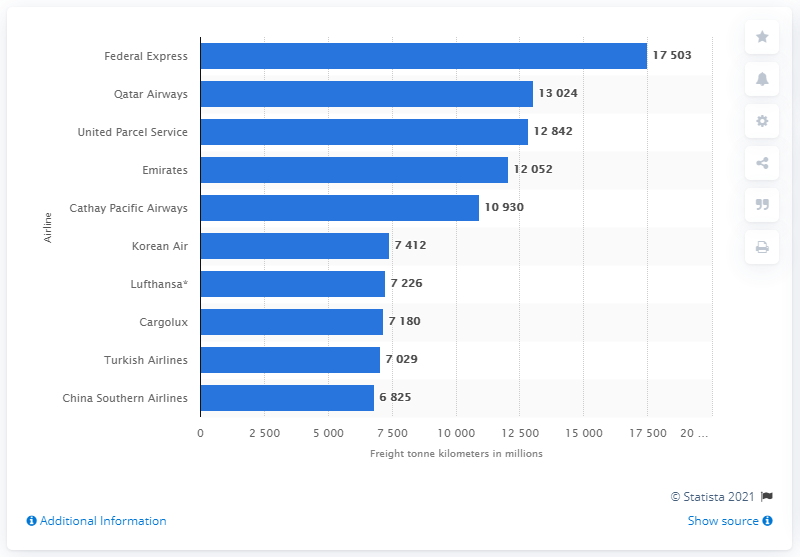Point out several critical features in this image. In 2019, Qatar Airways was the second largest airline in the world in terms of passengers carried and revenue generated. 